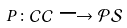<formula> <loc_0><loc_0><loc_500><loc_500>P \colon \mathcal { C C } \longrightarrow \mathcal { P S }</formula> 